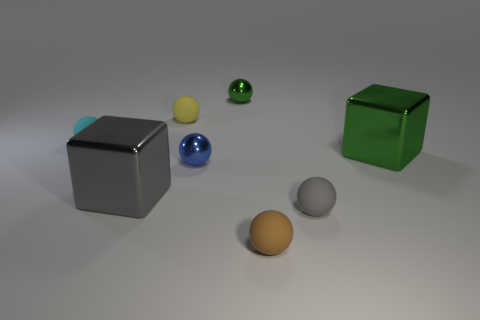There is a tiny yellow thing; are there any matte things left of it?
Make the answer very short. Yes. What is the thing that is both behind the cyan object and to the right of the small yellow rubber thing made of?
Make the answer very short. Metal. Is the big object that is on the left side of the small green sphere made of the same material as the large green object?
Make the answer very short. Yes. What is the green ball made of?
Offer a very short reply. Metal. What is the size of the metal ball that is behind the small yellow sphere?
Your answer should be very brief. Small. Are there any metallic blocks to the left of the tiny ball left of the big thing that is to the left of the gray sphere?
Provide a short and direct response. No. What number of blocks are either small brown matte things or small blue metallic things?
Offer a terse response. 0. What is the shape of the tiny gray object that is left of the block that is right of the green metallic ball?
Your answer should be compact. Sphere. There is a shiny thing that is to the left of the tiny metallic object in front of the metallic cube that is on the right side of the small gray matte object; what size is it?
Your answer should be compact. Large. Is the size of the brown matte object the same as the green cube?
Make the answer very short. No. 